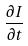Convert formula to latex. <formula><loc_0><loc_0><loc_500><loc_500>\frac { \partial I } { \partial t }</formula> 